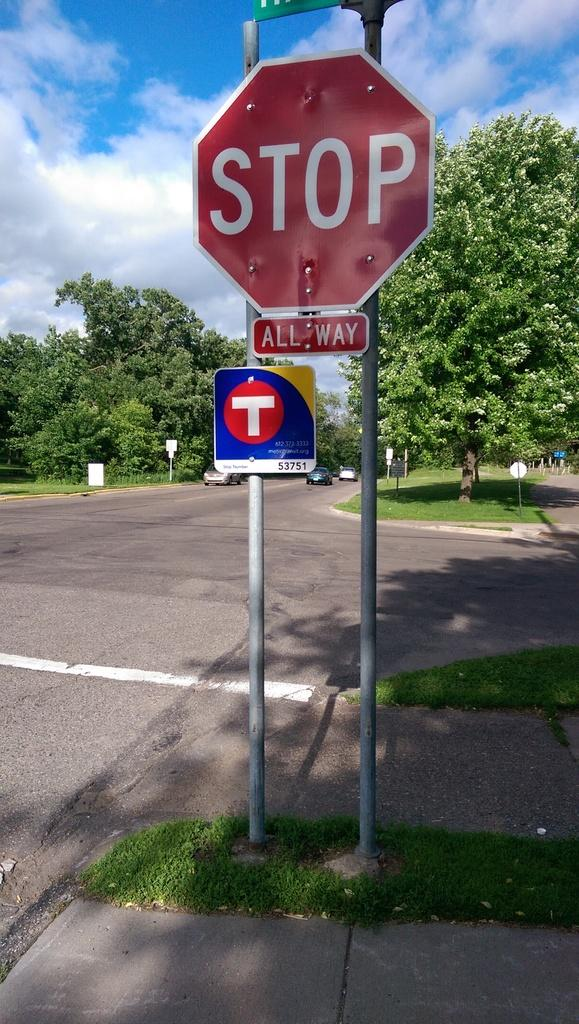<image>
Describe the image concisely. The stop sign shown is meant for an all way stop 